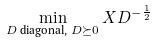<formula> <loc_0><loc_0><loc_500><loc_500>\min _ { D \text { diagonal, } D \succeq 0 } X D ^ { - \frac { 1 } { 2 } }</formula> 